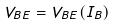Convert formula to latex. <formula><loc_0><loc_0><loc_500><loc_500>V _ { B E } = V _ { B E } ( I _ { B } )</formula> 